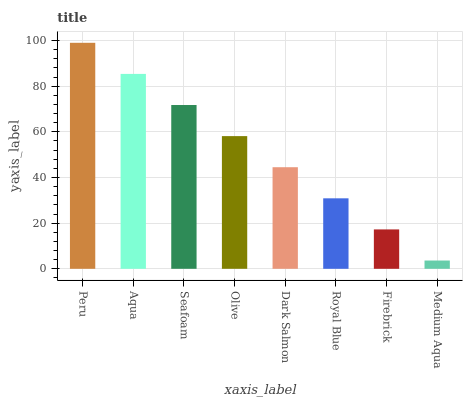Is Medium Aqua the minimum?
Answer yes or no. Yes. Is Peru the maximum?
Answer yes or no. Yes. Is Aqua the minimum?
Answer yes or no. No. Is Aqua the maximum?
Answer yes or no. No. Is Peru greater than Aqua?
Answer yes or no. Yes. Is Aqua less than Peru?
Answer yes or no. Yes. Is Aqua greater than Peru?
Answer yes or no. No. Is Peru less than Aqua?
Answer yes or no. No. Is Olive the high median?
Answer yes or no. Yes. Is Dark Salmon the low median?
Answer yes or no. Yes. Is Dark Salmon the high median?
Answer yes or no. No. Is Firebrick the low median?
Answer yes or no. No. 